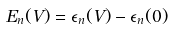<formula> <loc_0><loc_0><loc_500><loc_500>E _ { n } ( V ) = \epsilon _ { n } ( V ) - \epsilon _ { n } ( 0 )</formula> 